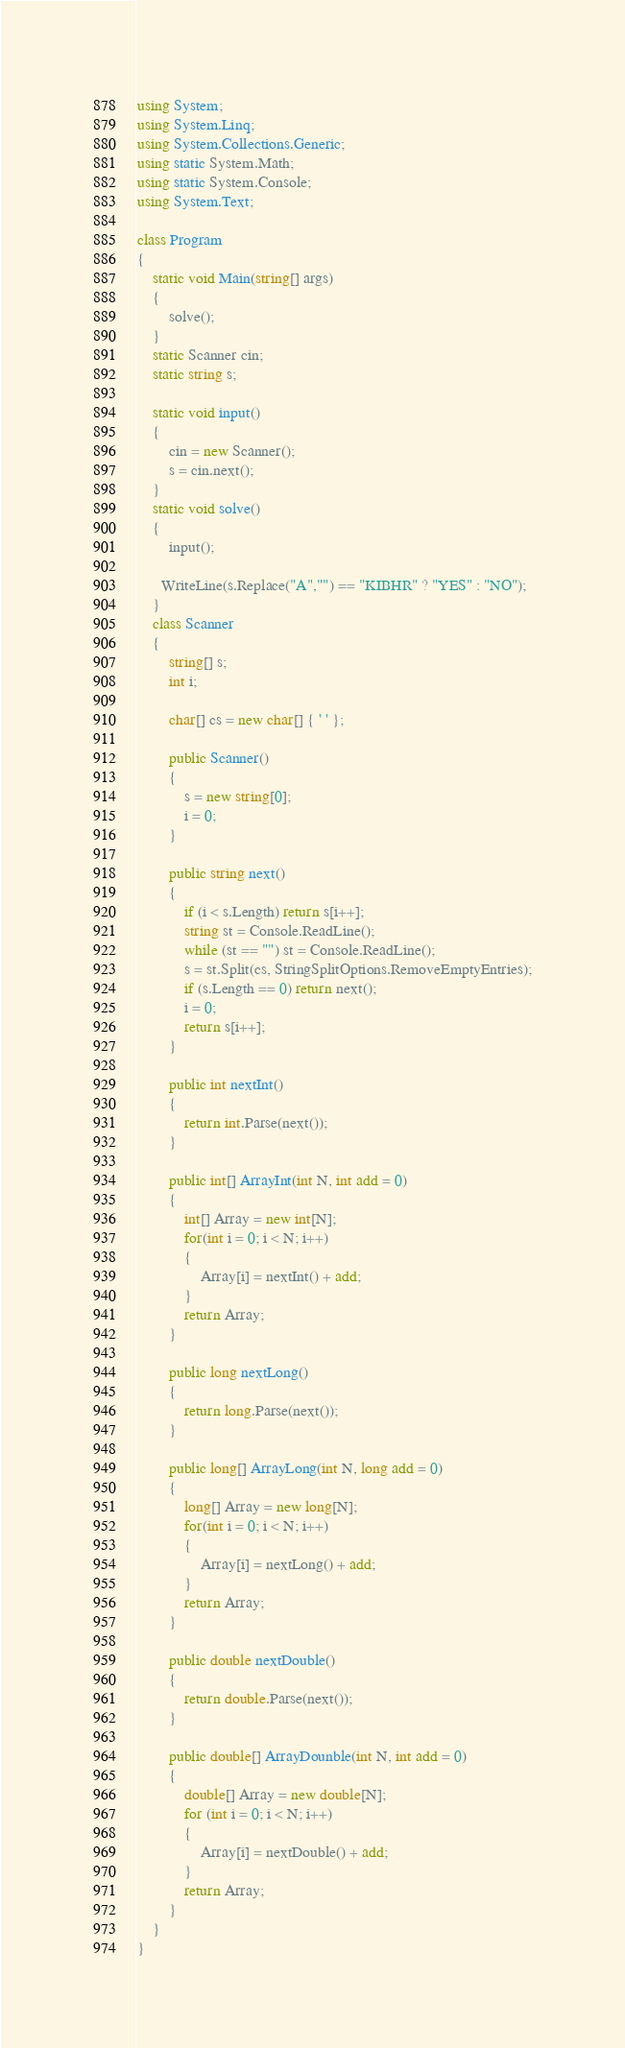<code> <loc_0><loc_0><loc_500><loc_500><_C#_>using System;
using System.Linq;
using System.Collections.Generic;
using static System.Math;
using static System.Console;
using System.Text;

class Program
{
    static void Main(string[] args)
    {
        solve();
    }
    static Scanner cin;
    static string s;

    static void input()
    {
        cin = new Scanner();
        s = cin.next();
    }
    static void solve()
    {
        input();
      
      WriteLine(s.Replace("A","") == "KIBHR" ? "YES" : "NO");
    }
    class Scanner
    {
        string[] s;
        int i;

        char[] cs = new char[] { ' ' };

        public Scanner()
        {
            s = new string[0];
            i = 0;
        }
        
        public string next()
        {
            if (i < s.Length) return s[i++];
            string st = Console.ReadLine();
            while (st == "") st = Console.ReadLine();
            s = st.Split(cs, StringSplitOptions.RemoveEmptyEntries);
            if (s.Length == 0) return next();
            i = 0;
            return s[i++];
        }

        public int nextInt()
        {
            return int.Parse(next());
        }

        public int[] ArrayInt(int N, int add = 0)
        {
            int[] Array = new int[N];
            for(int i = 0; i < N; i++)
            {
                Array[i] = nextInt() + add;
            }
            return Array;
        }

        public long nextLong()
        {
            return long.Parse(next());
        }

        public long[] ArrayLong(int N, long add = 0)
        {
            long[] Array = new long[N];
            for(int i = 0; i < N; i++)
            {
                Array[i] = nextLong() + add;
            }
            return Array;
        }

        public double nextDouble()
        {
            return double.Parse(next());
        }

        public double[] ArrayDounble(int N, int add = 0)
        {
            double[] Array = new double[N];
            for (int i = 0; i < N; i++)
            {
                Array[i] = nextDouble() + add;
            }
            return Array;
        }
    }
}
</code> 